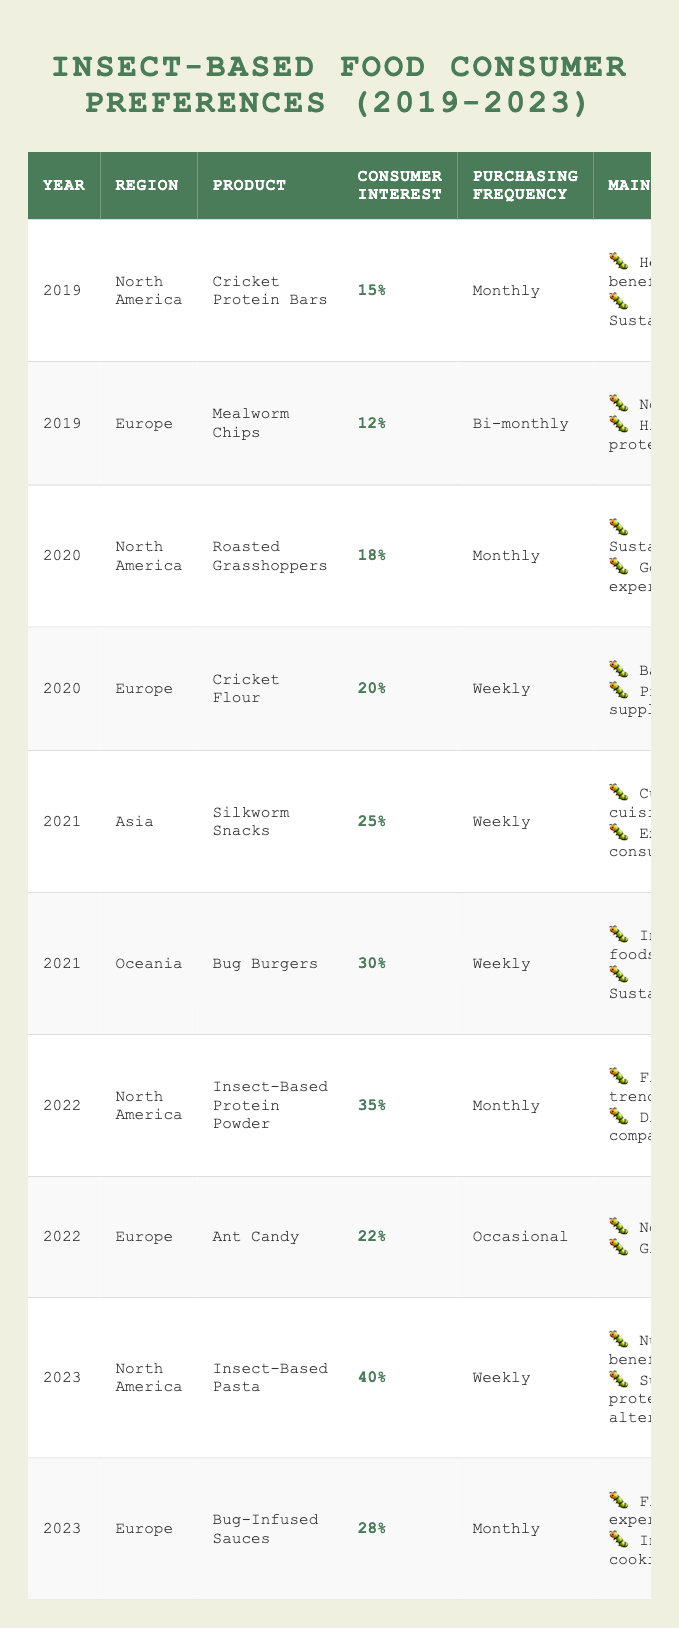What was the consumer interest percentage for Cricket Protein Bars in 2019? The table shows that the consumer interest percentage for Cricket Protein Bars in 2019 is 15%.
Answer: 15% Which product had the highest consumer interest percentage in 2023? According to the table, Insect-Based Pasta had the highest consumer interest percentage in 2023 at 40%.
Answer: Insect-Based Pasta How often did consumers purchase Bug Burgers in 2021? The table indicates that consumers purchased Bug Burgers weekly in 2021.
Answer: Weekly What were the main reasons for consumer interest in Mealworm Chips? The table lists "Novelty" and "High protein content" as the main reasons for consumer interest in Mealworm Chips.
Answer: Novelty, High protein content Which product had a higher consumer interest percentage in 2022, Insect-Based Protein Powder or Ant Candy? Insect-Based Protein Powder had a consumer interest percentage of 35%, while Ant Candy had 22%. Therefore, Insect-Based Protein Powder had the higher percentage.
Answer: Insect-Based Protein Powder Did the consumer interest in insect-based food products generally increase from 2019 to 2023? By examining the consumer interest percentages for each year, the values are 15%, 18%, 25%, 35%, and 40%, indicating an overall increase.
Answer: Yes What is the purchasing frequency of Roasted Grasshoppers in 2020? According to the table, Roasted Grasshoppers were purchased monthly in 2020.
Answer: Monthly Which year saw the introduction of the highest consumer interest product in Asia and what was it? In 2021, the product "Silkworm Snacks" had the highest consumer interest in Asia at 25%.
Answer: 2021, Silkworm Snacks What are the main reasons consumers favored Insect-Based Pasta in 2023? The reasons listed for favoring Insect-Based Pasta in 2023 are "Nutritional benefits" and "Sustainable protein alternative".
Answer: Nutritional benefits, Sustainable protein alternative How does the consumer interest for Cricket Flour in 2020 compare to the consumer interest for Mealworm Chips in 2019? Cricket Flour had a consumer interest of 20% in 2020, while Mealworm Chips had 12% in 2019. Thus, Cricket Flour had a higher interest percentage by 8%.
Answer: Higher by 8% What was the average consumer interest percentage for Insect-Based products from 2019 to 2023? The consumer interest percentages are: 15%, 12%, 18%, 20%, 25%, 30%, 35%, 22%, 40%, 28%. Summing these gives 320, and there are 10 values, so the average is 320/10 = 32%.
Answer: 32% Which awareness campaign coincided with the launch of Insect-Based Protein Powder in 2022? The awareness campaign mentioned in the table for Insect-Based Protein Powder in 2022 is the "Fit with Bugs Challenge."
Answer: Fit with Bugs Challenge How many insect-based food products were introduced in 2021? From the table, two products were introduced in 2021: Silkworm Snacks and Bug Burgers.
Answer: 2 What evidence suggests that consumer interest in insect-based food was affected by awareness campaigns? The consumer interest percentages show increases following campaigns such as "Pasta with Purpose" in 2023 and "Fit with Bugs Challenge" in 2022, which likely raised awareness about these products.
Answer: Evidence suggests awareness campaigns positively affected interest 